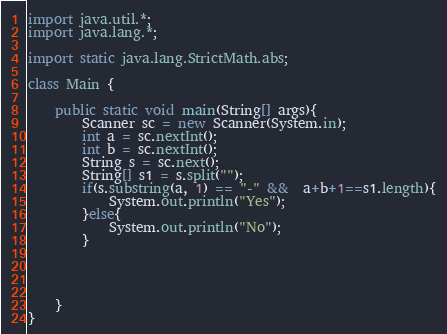Convert code to text. <code><loc_0><loc_0><loc_500><loc_500><_Java_>import java.util.*;
import java.lang.*;

import static java.lang.StrictMath.abs;

class Main {

    public static void main(String[] args){
        Scanner sc = new Scanner(System.in);
        int a = sc.nextInt();
        int b = sc.nextInt();
        String s = sc.next();
        String[] s1 = s.split("");
        if(s.substring(a, 1) == "-" &&  a+b+1==s1.length){
            System.out.println("Yes");
        }else{
            System.out.println("No");
        }




    }
}</code> 